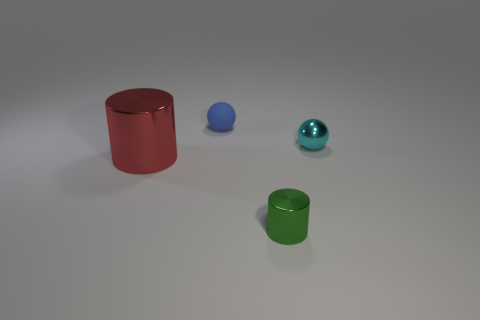Add 2 green metal cylinders. How many objects exist? 6 Add 4 small matte objects. How many small matte objects are left? 5 Add 1 big red metal things. How many big red metal things exist? 2 Subtract 0 purple cylinders. How many objects are left? 4 Subtract all green metal blocks. Subtract all tiny balls. How many objects are left? 2 